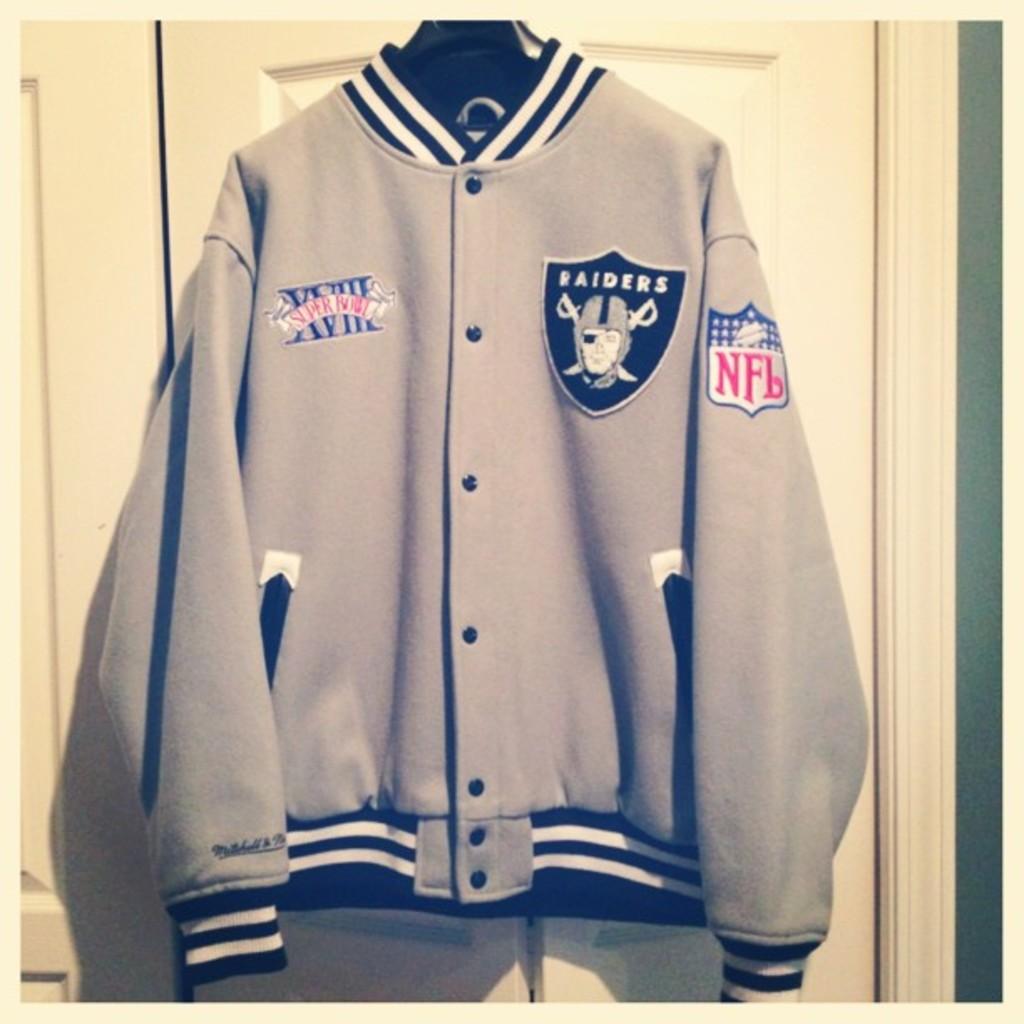What bowl game is written in red on this jacket?
Your answer should be compact. Super bowl. 